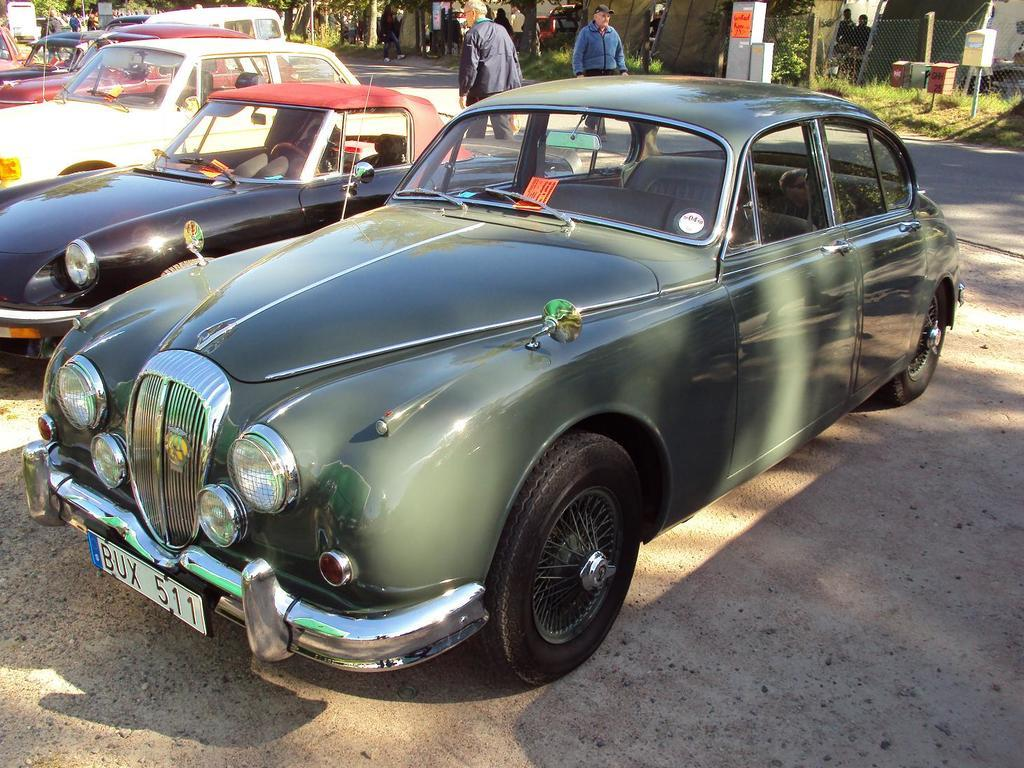What types of vehicles can be seen in the image? There are vehicles of different colors in the image. Where are the vehicles located in the image? The vehicles are parked on the ground. What can be seen in the background of the image? There are persons, a road, trees, plants, and grass visible in the background. What type of locket is being used to connect the vehicles in the image? There is no locket present in the image, nor are the vehicles connected in any way. How much money is being exchanged between the persons in the background of the image? There is no indication of any money exchange in the image; the persons in the background are not interacting with each other. 